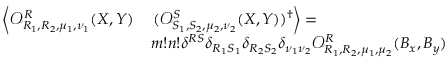Convert formula to latex. <formula><loc_0><loc_0><loc_500><loc_500>\begin{array} { r l } { \left \langle \mathcal { O } _ { R _ { 1 } , R _ { 2 } , \mu _ { 1 } , \nu _ { 1 } } ^ { R } ( X , Y ) } & { ( \mathcal { O } _ { S _ { 1 } , S _ { 2 } , \mu _ { 2 } , \nu _ { 2 } } ^ { S } ( X , Y ) ) ^ { \dagger } \right \rangle = } \\ & { m ! n ! \delta ^ { R S } \delta _ { R _ { 1 } S _ { 1 } } \delta _ { R _ { 2 } S _ { 2 } } \delta _ { \nu _ { 1 } \nu _ { 2 } } \mathcal { O } _ { R _ { 1 } , R _ { 2 } , \mu _ { 1 } , \mu _ { 2 } } ^ { R } ( B _ { x } , B _ { y } ) } \end{array}</formula> 